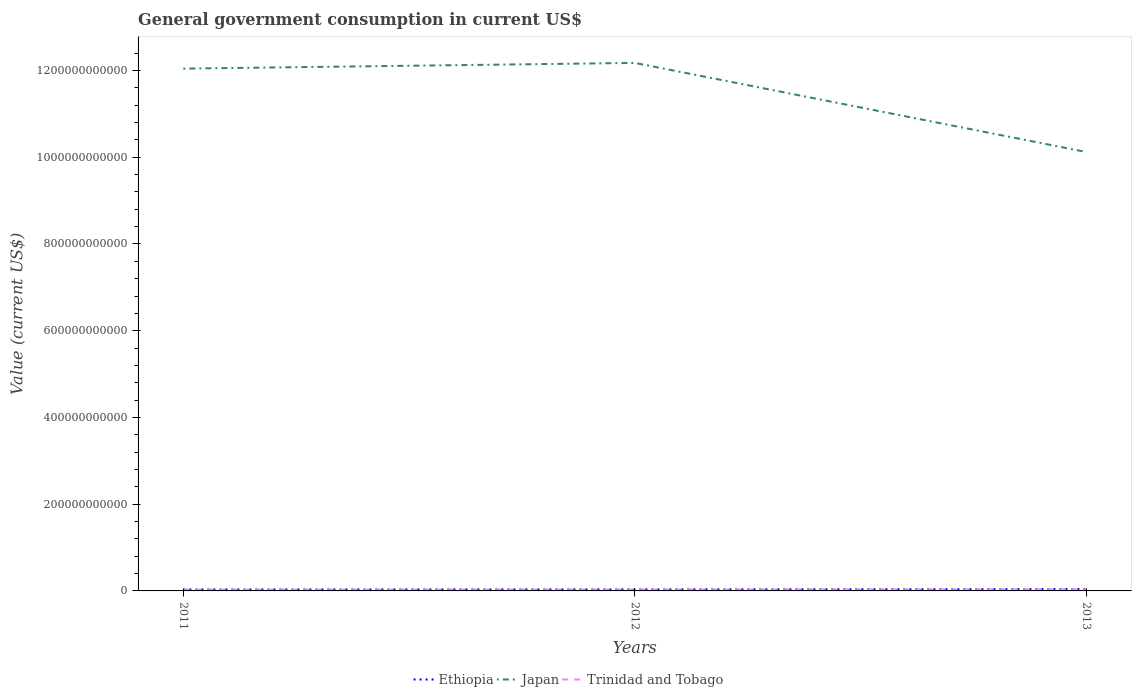Is the number of lines equal to the number of legend labels?
Offer a very short reply. Yes. Across all years, what is the maximum government conusmption in Ethiopia?
Offer a very short reply. 3.30e+09. In which year was the government conusmption in Ethiopia maximum?
Make the answer very short. 2011. What is the total government conusmption in Trinidad and Tobago in the graph?
Provide a short and direct response. -2.01e+08. What is the difference between the highest and the second highest government conusmption in Ethiopia?
Provide a short and direct response. 9.70e+08. What is the difference between the highest and the lowest government conusmption in Japan?
Make the answer very short. 2. How many lines are there?
Give a very brief answer. 3. What is the difference between two consecutive major ticks on the Y-axis?
Ensure brevity in your answer.  2.00e+11. Are the values on the major ticks of Y-axis written in scientific E-notation?
Provide a short and direct response. No. Where does the legend appear in the graph?
Give a very brief answer. Bottom center. How many legend labels are there?
Ensure brevity in your answer.  3. How are the legend labels stacked?
Make the answer very short. Horizontal. What is the title of the graph?
Your answer should be very brief. General government consumption in current US$. Does "Nepal" appear as one of the legend labels in the graph?
Your response must be concise. No. What is the label or title of the X-axis?
Keep it short and to the point. Years. What is the label or title of the Y-axis?
Ensure brevity in your answer.  Value (current US$). What is the Value (current US$) of Ethiopia in 2011?
Keep it short and to the point. 3.30e+09. What is the Value (current US$) in Japan in 2011?
Offer a very short reply. 1.20e+12. What is the Value (current US$) in Trinidad and Tobago in 2011?
Your answer should be very brief. 2.96e+09. What is the Value (current US$) in Ethiopia in 2012?
Ensure brevity in your answer.  3.60e+09. What is the Value (current US$) of Japan in 2012?
Ensure brevity in your answer.  1.22e+12. What is the Value (current US$) of Trinidad and Tobago in 2012?
Keep it short and to the point. 3.16e+09. What is the Value (current US$) in Ethiopia in 2013?
Your answer should be very brief. 4.27e+09. What is the Value (current US$) of Japan in 2013?
Your response must be concise. 1.01e+12. What is the Value (current US$) of Trinidad and Tobago in 2013?
Provide a succinct answer. 3.50e+09. Across all years, what is the maximum Value (current US$) in Ethiopia?
Your response must be concise. 4.27e+09. Across all years, what is the maximum Value (current US$) of Japan?
Offer a terse response. 1.22e+12. Across all years, what is the maximum Value (current US$) of Trinidad and Tobago?
Your response must be concise. 3.50e+09. Across all years, what is the minimum Value (current US$) in Ethiopia?
Provide a succinct answer. 3.30e+09. Across all years, what is the minimum Value (current US$) of Japan?
Give a very brief answer. 1.01e+12. Across all years, what is the minimum Value (current US$) in Trinidad and Tobago?
Make the answer very short. 2.96e+09. What is the total Value (current US$) in Ethiopia in the graph?
Make the answer very short. 1.12e+1. What is the total Value (current US$) in Japan in the graph?
Offer a terse response. 3.43e+12. What is the total Value (current US$) of Trinidad and Tobago in the graph?
Ensure brevity in your answer.  9.62e+09. What is the difference between the Value (current US$) of Ethiopia in 2011 and that in 2012?
Make the answer very short. -2.99e+08. What is the difference between the Value (current US$) in Japan in 2011 and that in 2012?
Keep it short and to the point. -1.31e+1. What is the difference between the Value (current US$) in Trinidad and Tobago in 2011 and that in 2012?
Your response must be concise. -2.01e+08. What is the difference between the Value (current US$) of Ethiopia in 2011 and that in 2013?
Give a very brief answer. -9.70e+08. What is the difference between the Value (current US$) of Japan in 2011 and that in 2013?
Offer a terse response. 1.92e+11. What is the difference between the Value (current US$) of Trinidad and Tobago in 2011 and that in 2013?
Ensure brevity in your answer.  -5.35e+08. What is the difference between the Value (current US$) in Ethiopia in 2012 and that in 2013?
Keep it short and to the point. -6.71e+08. What is the difference between the Value (current US$) of Japan in 2012 and that in 2013?
Your answer should be compact. 2.05e+11. What is the difference between the Value (current US$) in Trinidad and Tobago in 2012 and that in 2013?
Your answer should be very brief. -3.34e+08. What is the difference between the Value (current US$) in Ethiopia in 2011 and the Value (current US$) in Japan in 2012?
Your answer should be compact. -1.21e+12. What is the difference between the Value (current US$) in Ethiopia in 2011 and the Value (current US$) in Trinidad and Tobago in 2012?
Provide a short and direct response. 1.33e+08. What is the difference between the Value (current US$) of Japan in 2011 and the Value (current US$) of Trinidad and Tobago in 2012?
Provide a short and direct response. 1.20e+12. What is the difference between the Value (current US$) in Ethiopia in 2011 and the Value (current US$) in Japan in 2013?
Provide a succinct answer. -1.01e+12. What is the difference between the Value (current US$) of Ethiopia in 2011 and the Value (current US$) of Trinidad and Tobago in 2013?
Ensure brevity in your answer.  -2.01e+08. What is the difference between the Value (current US$) in Japan in 2011 and the Value (current US$) in Trinidad and Tobago in 2013?
Your answer should be very brief. 1.20e+12. What is the difference between the Value (current US$) in Ethiopia in 2012 and the Value (current US$) in Japan in 2013?
Your answer should be compact. -1.01e+12. What is the difference between the Value (current US$) in Ethiopia in 2012 and the Value (current US$) in Trinidad and Tobago in 2013?
Ensure brevity in your answer.  9.81e+07. What is the difference between the Value (current US$) of Japan in 2012 and the Value (current US$) of Trinidad and Tobago in 2013?
Provide a succinct answer. 1.21e+12. What is the average Value (current US$) of Ethiopia per year?
Keep it short and to the point. 3.72e+09. What is the average Value (current US$) in Japan per year?
Provide a short and direct response. 1.14e+12. What is the average Value (current US$) in Trinidad and Tobago per year?
Ensure brevity in your answer.  3.21e+09. In the year 2011, what is the difference between the Value (current US$) in Ethiopia and Value (current US$) in Japan?
Keep it short and to the point. -1.20e+12. In the year 2011, what is the difference between the Value (current US$) in Ethiopia and Value (current US$) in Trinidad and Tobago?
Your answer should be compact. 3.34e+08. In the year 2011, what is the difference between the Value (current US$) in Japan and Value (current US$) in Trinidad and Tobago?
Provide a short and direct response. 1.20e+12. In the year 2012, what is the difference between the Value (current US$) in Ethiopia and Value (current US$) in Japan?
Ensure brevity in your answer.  -1.21e+12. In the year 2012, what is the difference between the Value (current US$) in Ethiopia and Value (current US$) in Trinidad and Tobago?
Ensure brevity in your answer.  4.32e+08. In the year 2012, what is the difference between the Value (current US$) of Japan and Value (current US$) of Trinidad and Tobago?
Your answer should be compact. 1.21e+12. In the year 2013, what is the difference between the Value (current US$) of Ethiopia and Value (current US$) of Japan?
Your answer should be very brief. -1.01e+12. In the year 2013, what is the difference between the Value (current US$) of Ethiopia and Value (current US$) of Trinidad and Tobago?
Provide a succinct answer. 7.69e+08. In the year 2013, what is the difference between the Value (current US$) in Japan and Value (current US$) in Trinidad and Tobago?
Keep it short and to the point. 1.01e+12. What is the ratio of the Value (current US$) of Ethiopia in 2011 to that in 2012?
Ensure brevity in your answer.  0.92. What is the ratio of the Value (current US$) in Trinidad and Tobago in 2011 to that in 2012?
Offer a very short reply. 0.94. What is the ratio of the Value (current US$) of Ethiopia in 2011 to that in 2013?
Offer a terse response. 0.77. What is the ratio of the Value (current US$) of Japan in 2011 to that in 2013?
Make the answer very short. 1.19. What is the ratio of the Value (current US$) in Trinidad and Tobago in 2011 to that in 2013?
Keep it short and to the point. 0.85. What is the ratio of the Value (current US$) in Ethiopia in 2012 to that in 2013?
Ensure brevity in your answer.  0.84. What is the ratio of the Value (current US$) of Japan in 2012 to that in 2013?
Provide a succinct answer. 1.2. What is the ratio of the Value (current US$) of Trinidad and Tobago in 2012 to that in 2013?
Provide a short and direct response. 0.9. What is the difference between the highest and the second highest Value (current US$) of Ethiopia?
Offer a terse response. 6.71e+08. What is the difference between the highest and the second highest Value (current US$) in Japan?
Ensure brevity in your answer.  1.31e+1. What is the difference between the highest and the second highest Value (current US$) of Trinidad and Tobago?
Make the answer very short. 3.34e+08. What is the difference between the highest and the lowest Value (current US$) in Ethiopia?
Ensure brevity in your answer.  9.70e+08. What is the difference between the highest and the lowest Value (current US$) in Japan?
Give a very brief answer. 2.05e+11. What is the difference between the highest and the lowest Value (current US$) in Trinidad and Tobago?
Your answer should be compact. 5.35e+08. 